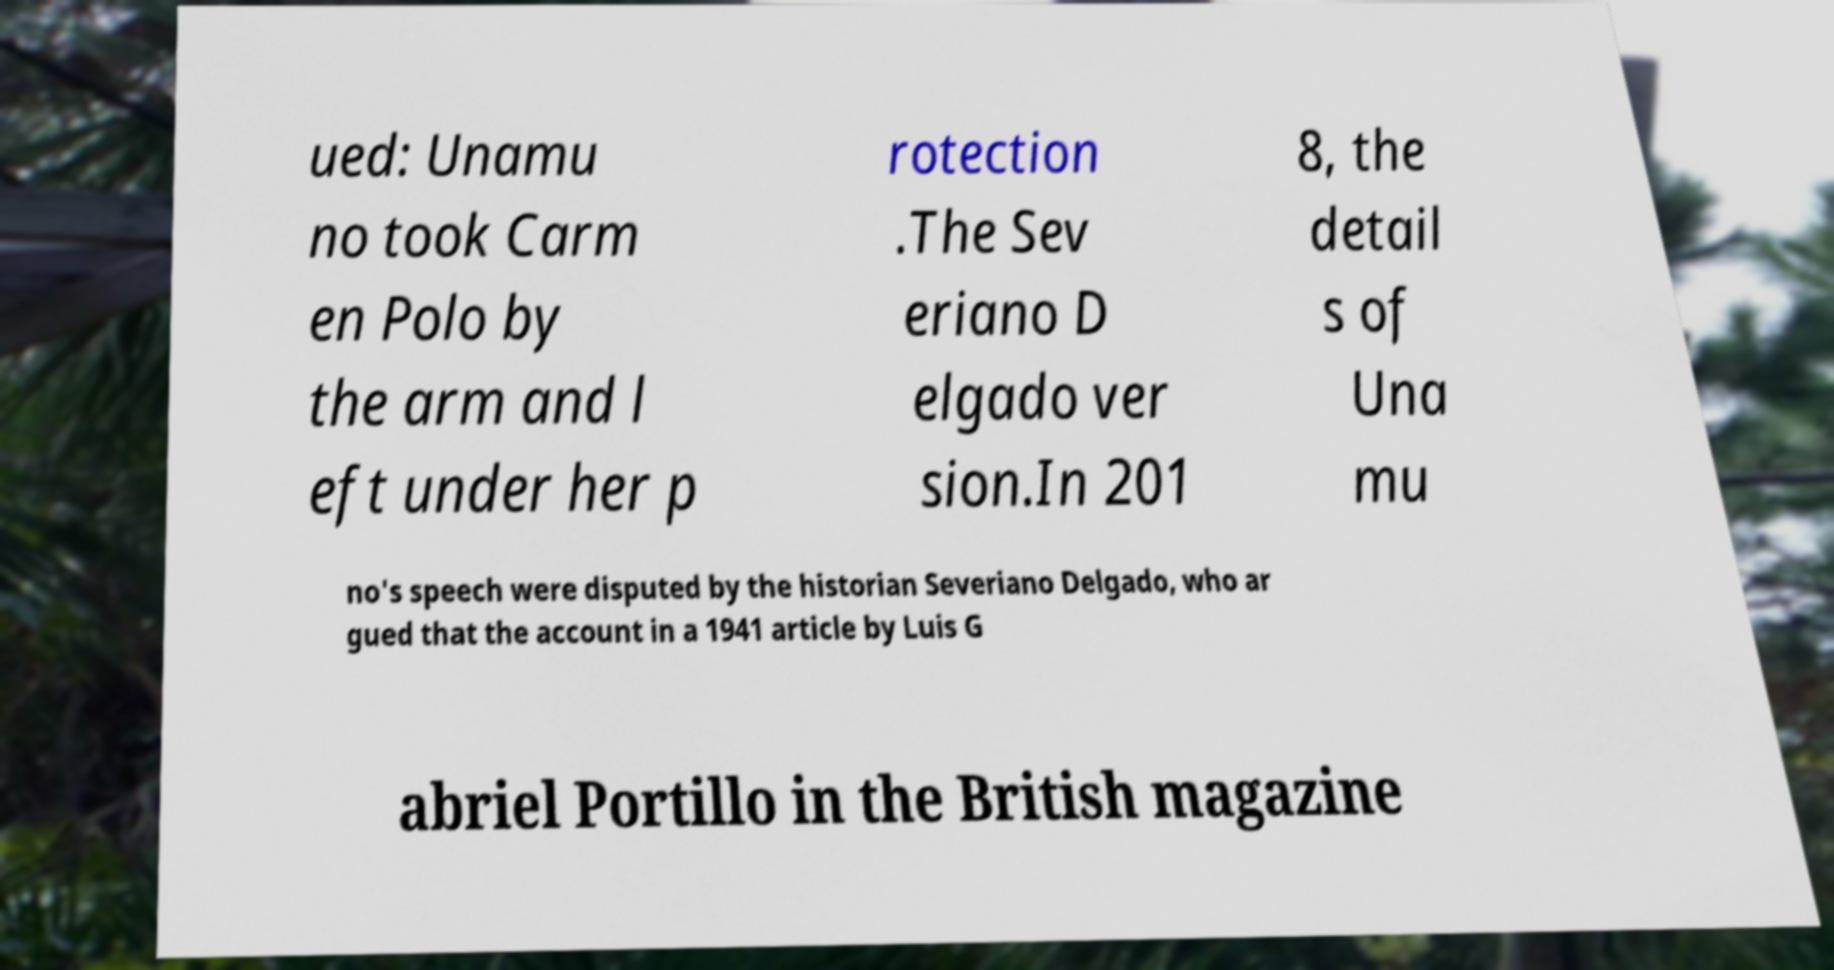There's text embedded in this image that I need extracted. Can you transcribe it verbatim? ued: Unamu no took Carm en Polo by the arm and l eft under her p rotection .The Sev eriano D elgado ver sion.In 201 8, the detail s of Una mu no's speech were disputed by the historian Severiano Delgado, who ar gued that the account in a 1941 article by Luis G abriel Portillo in the British magazine 